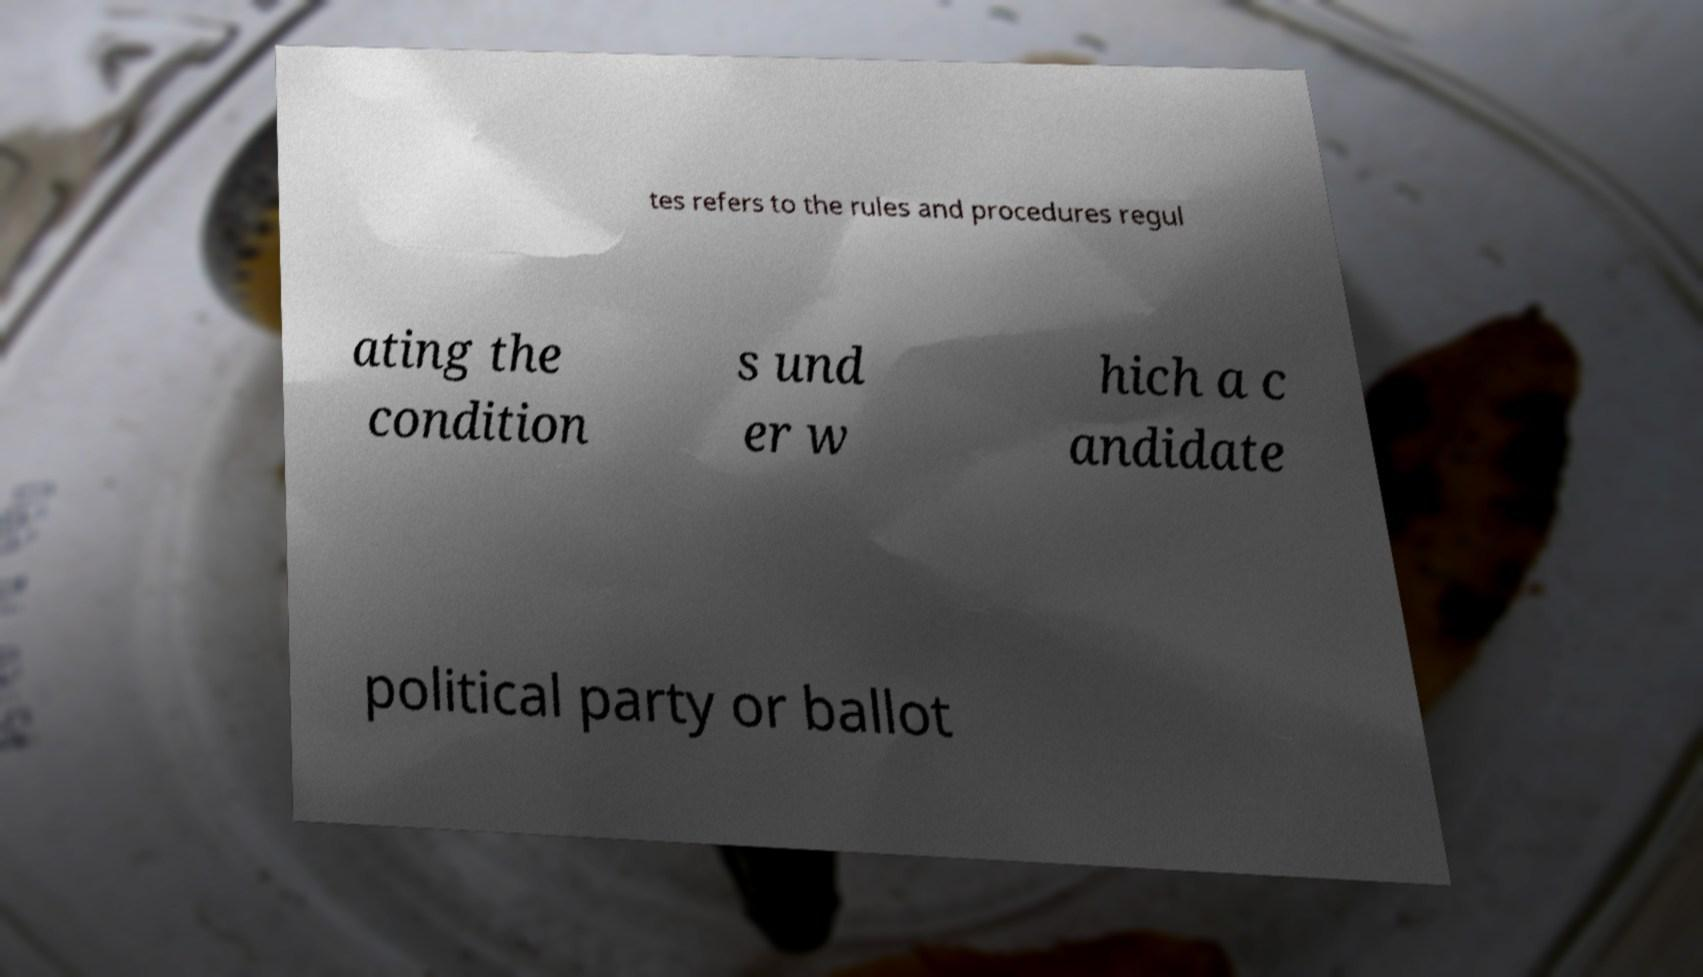There's text embedded in this image that I need extracted. Can you transcribe it verbatim? tes refers to the rules and procedures regul ating the condition s und er w hich a c andidate political party or ballot 